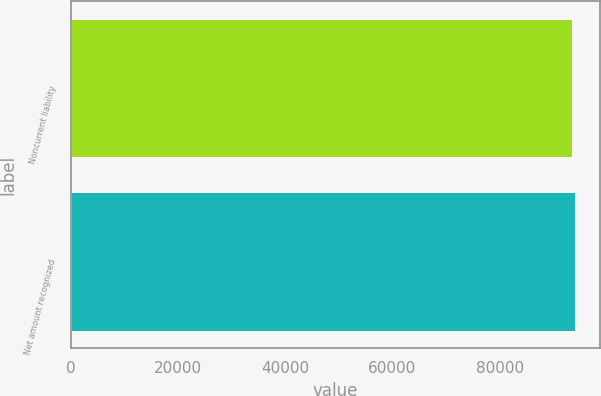Convert chart to OTSL. <chart><loc_0><loc_0><loc_500><loc_500><bar_chart><fcel>Noncurrent liability<fcel>Net amount recognized<nl><fcel>93530<fcel>93992<nl></chart> 